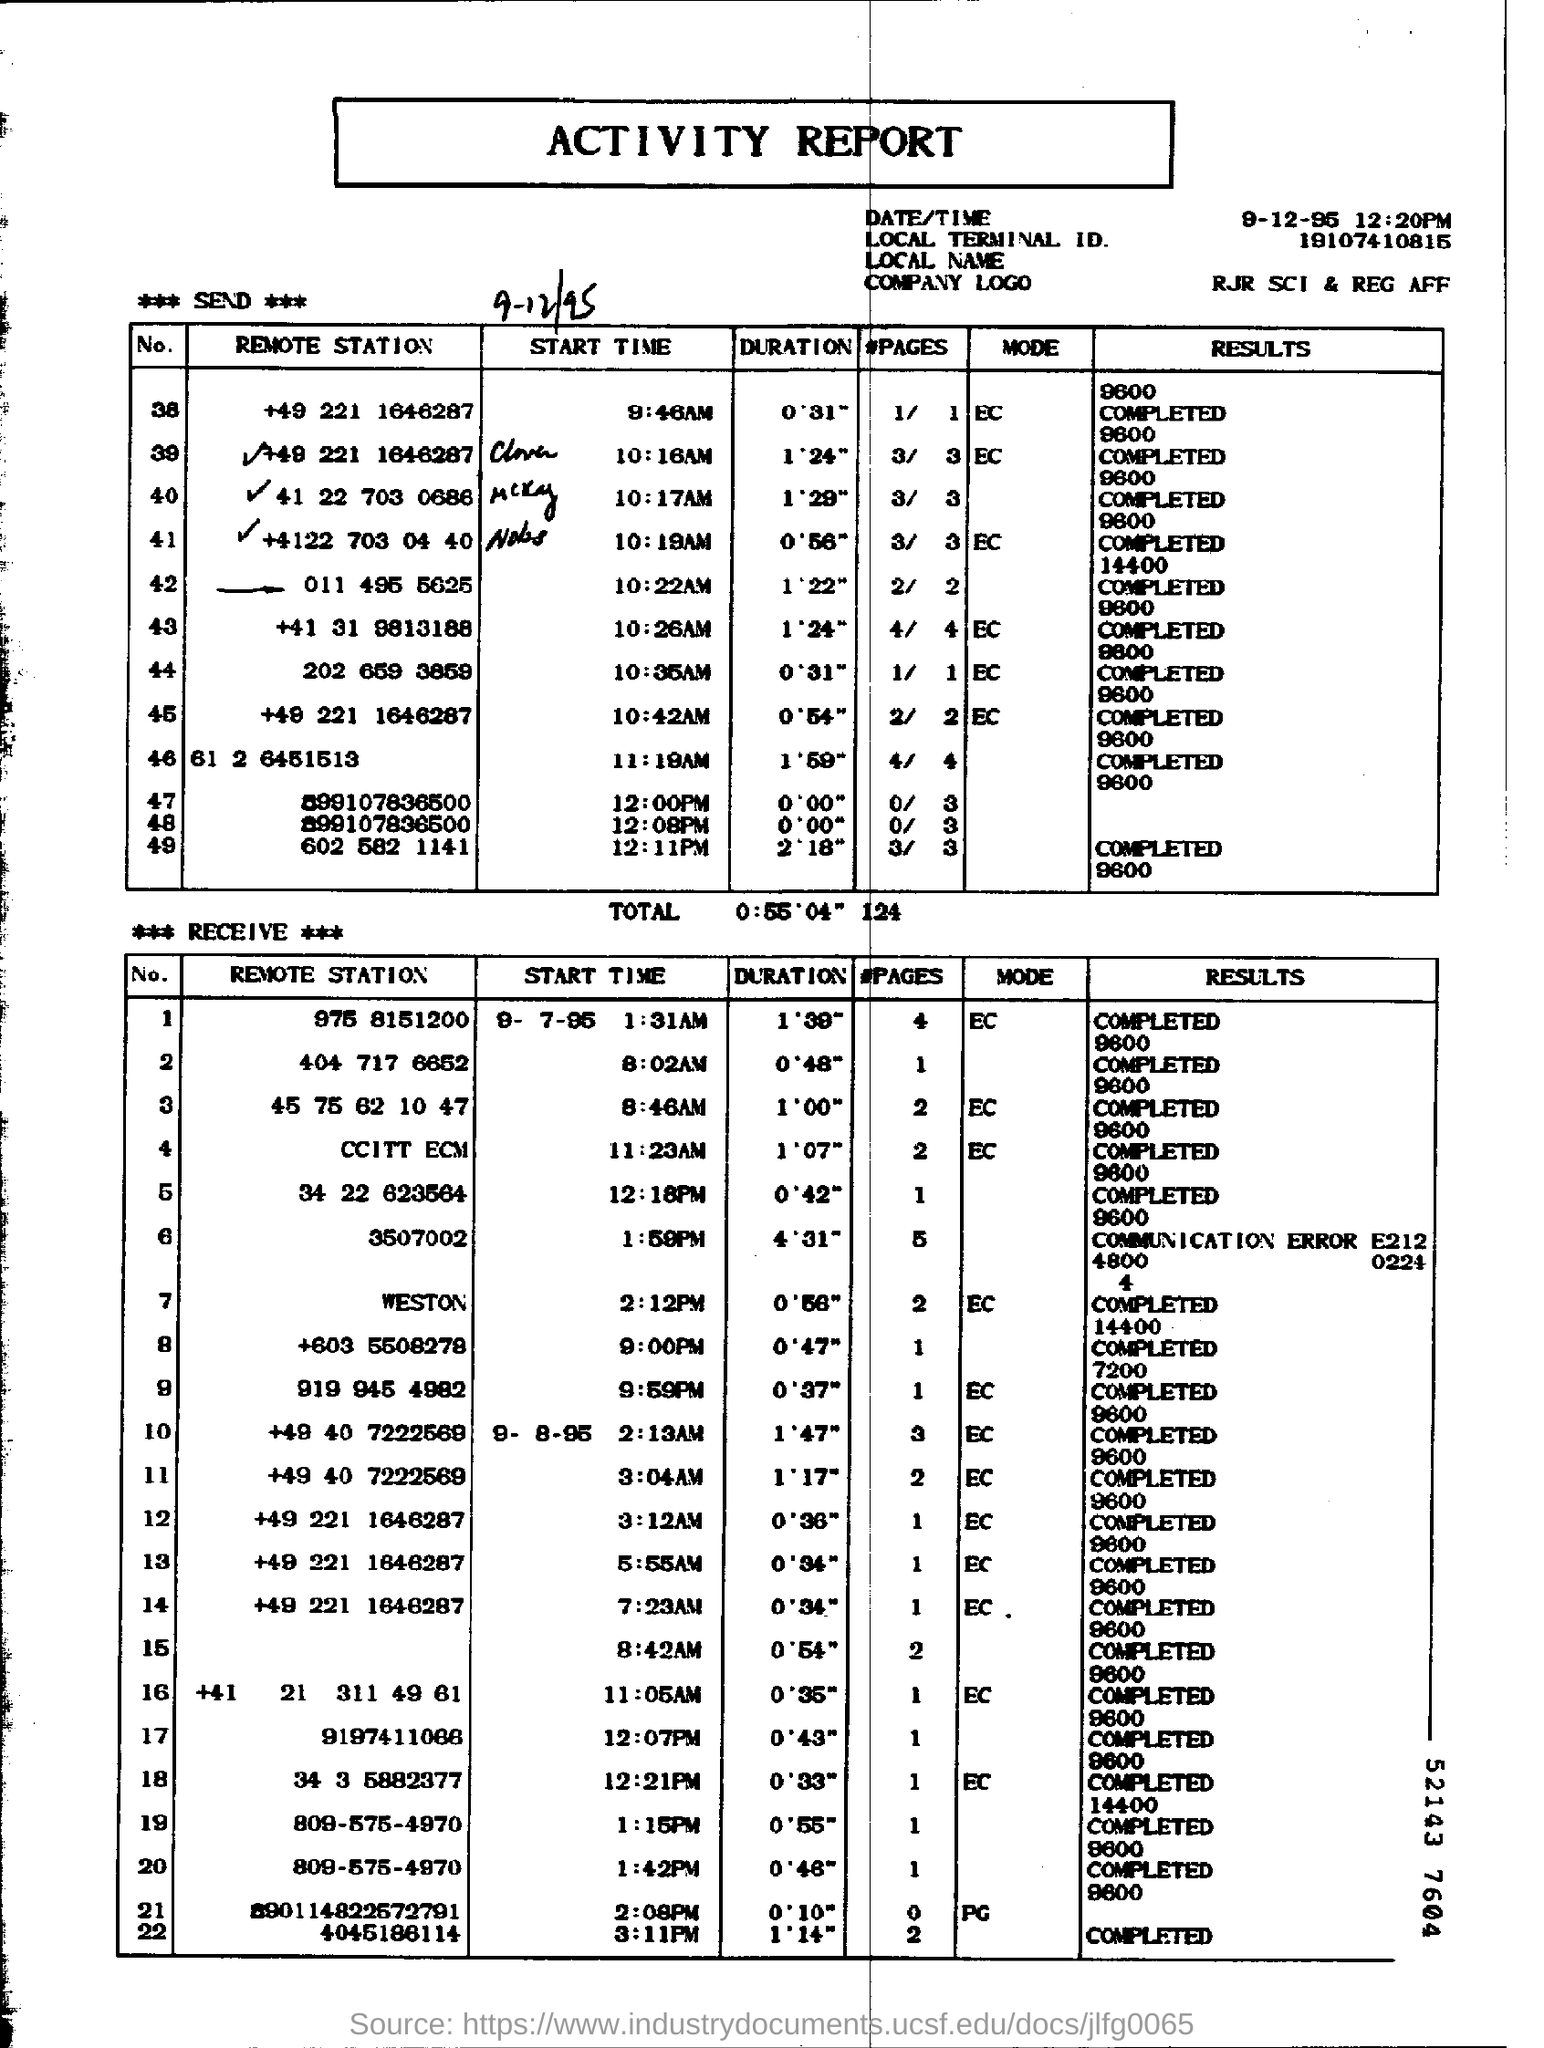What type of document is this?
Ensure brevity in your answer.  ACTIVITY REPORT. What is the local terminal ID.?
Keep it short and to the point. 19107410815. 